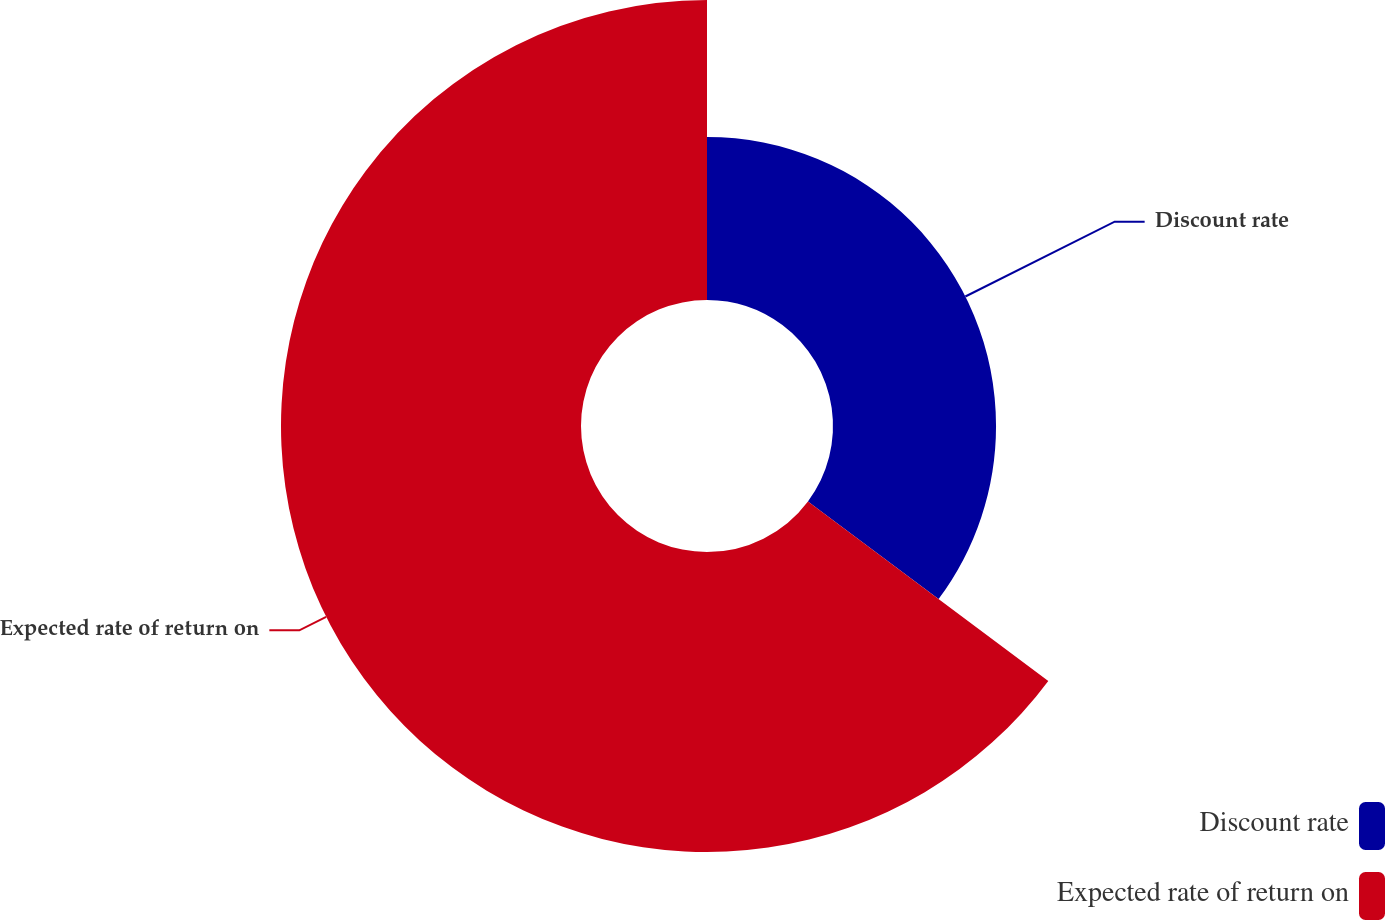Convert chart to OTSL. <chart><loc_0><loc_0><loc_500><loc_500><pie_chart><fcel>Discount rate<fcel>Expected rate of return on<nl><fcel>35.21%<fcel>64.79%<nl></chart> 